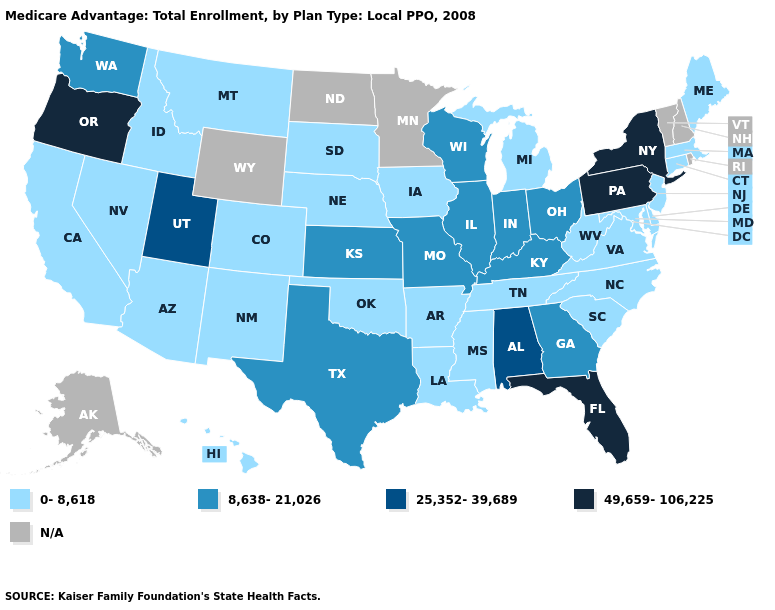Among the states that border Montana , which have the highest value?
Write a very short answer. Idaho, South Dakota. Name the states that have a value in the range 49,659-106,225?
Concise answer only. Florida, New York, Oregon, Pennsylvania. Among the states that border Ohio , which have the lowest value?
Answer briefly. Michigan, West Virginia. What is the highest value in the USA?
Short answer required. 49,659-106,225. What is the value of Florida?
Quick response, please. 49,659-106,225. Among the states that border Montana , which have the highest value?
Keep it brief. Idaho, South Dakota. Which states hav the highest value in the West?
Short answer required. Oregon. Does the first symbol in the legend represent the smallest category?
Answer briefly. Yes. What is the highest value in the USA?
Keep it brief. 49,659-106,225. Name the states that have a value in the range 8,638-21,026?
Concise answer only. Georgia, Illinois, Indiana, Kansas, Kentucky, Missouri, Ohio, Texas, Washington, Wisconsin. What is the value of Georgia?
Quick response, please. 8,638-21,026. Does Maine have the highest value in the Northeast?
Concise answer only. No. Does Kentucky have the highest value in the USA?
Concise answer only. No. Does Massachusetts have the lowest value in the Northeast?
Concise answer only. Yes. 